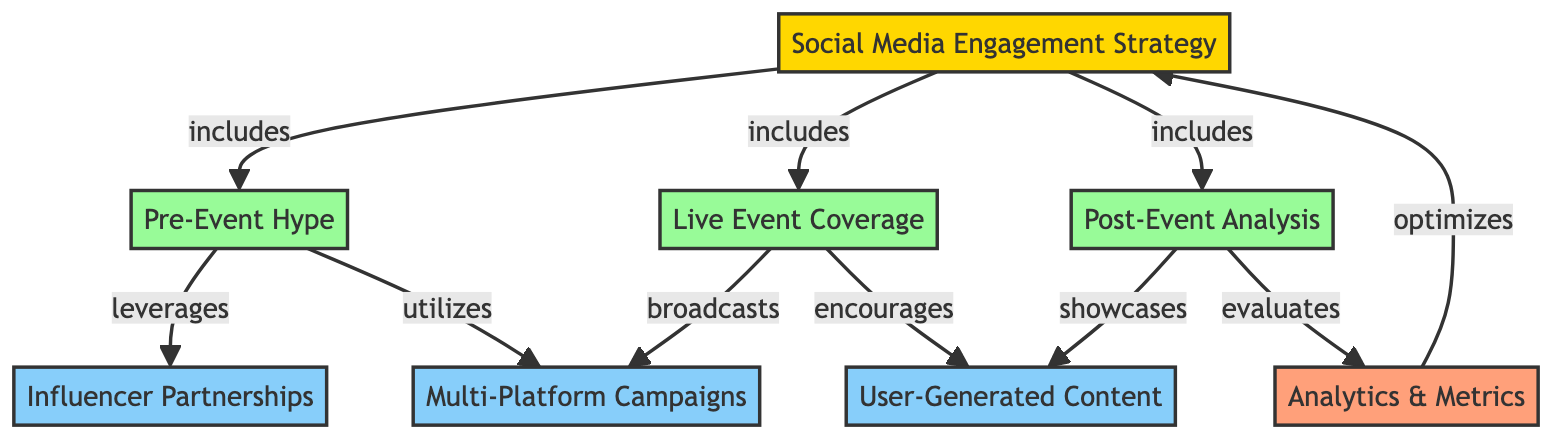What are the three main phases included in the Social Media Engagement Strategy? The diagram shows that the Social Media Engagement Strategy includes three phases: Pre-Event Hype, Live Event Coverage, and Post-Event Analysis.
Answer: Pre-Event Hype, Live Event Coverage, Post-Event Analysis What relationship exists between Pre-Event Hype and Influencer Partnerships? The diagram indicates that the Pre-Event Hype leverages Influencer Partnerships, which shows a direct connection and the way one influences or utilizes the other.
Answer: leverages How many total nodes are present in the diagram? By counting the nodes listed in the diagram, we find there are 8 nodes in total, each representing different components of the strategy.
Answer: 8 Which tactic is showcased during the Post-Event Analysis? The diagram highlights that during Post-Event Analysis, User-Generated Content is showcased, signifying its importance in the analysis phase.
Answer: User-Generated Content What does the Analytics & Metrics phase do concerning the Social Media Engagement Strategy? The diagram connects Analytics & Metrics to the Social Media Engagement Strategy with the relationship of optimizing, implying that metrics are used to enhance the overall strategy.
Answer: optimizes Which tactic is encouraged during Live Event Coverage? The diagram specifically states that Live Event Coverage encourages User-Generated Content, indicating a focus on audience engagement at that time.
Answer: User-Generated Content What type of campaign utilizes Pre-Event Hype? The relationship indicated in the diagram shows that Multi-Platform Campaigns utilize Pre-Event Hype, suggesting a strategy that encompasses various media platforms.
Answer: Multi-Platform Campaigns How does Post-Event Analysis evaluate the impact of the engagement strategy? The diagram indicates that Post-Event Analysis evaluates the impact through Analytics & Metrics, implying that data analysis is critical in understanding the effectiveness of the strategy.
Answer: evaluates What is the relationship between Live Event Coverage and Multi-Platform Campaigns? The diagram shows that Live Event Coverage broadcasts Multi-Platform Campaigns, indicating that the event coverage promotes and shares these campaigns widely.
Answer: broadcasts 